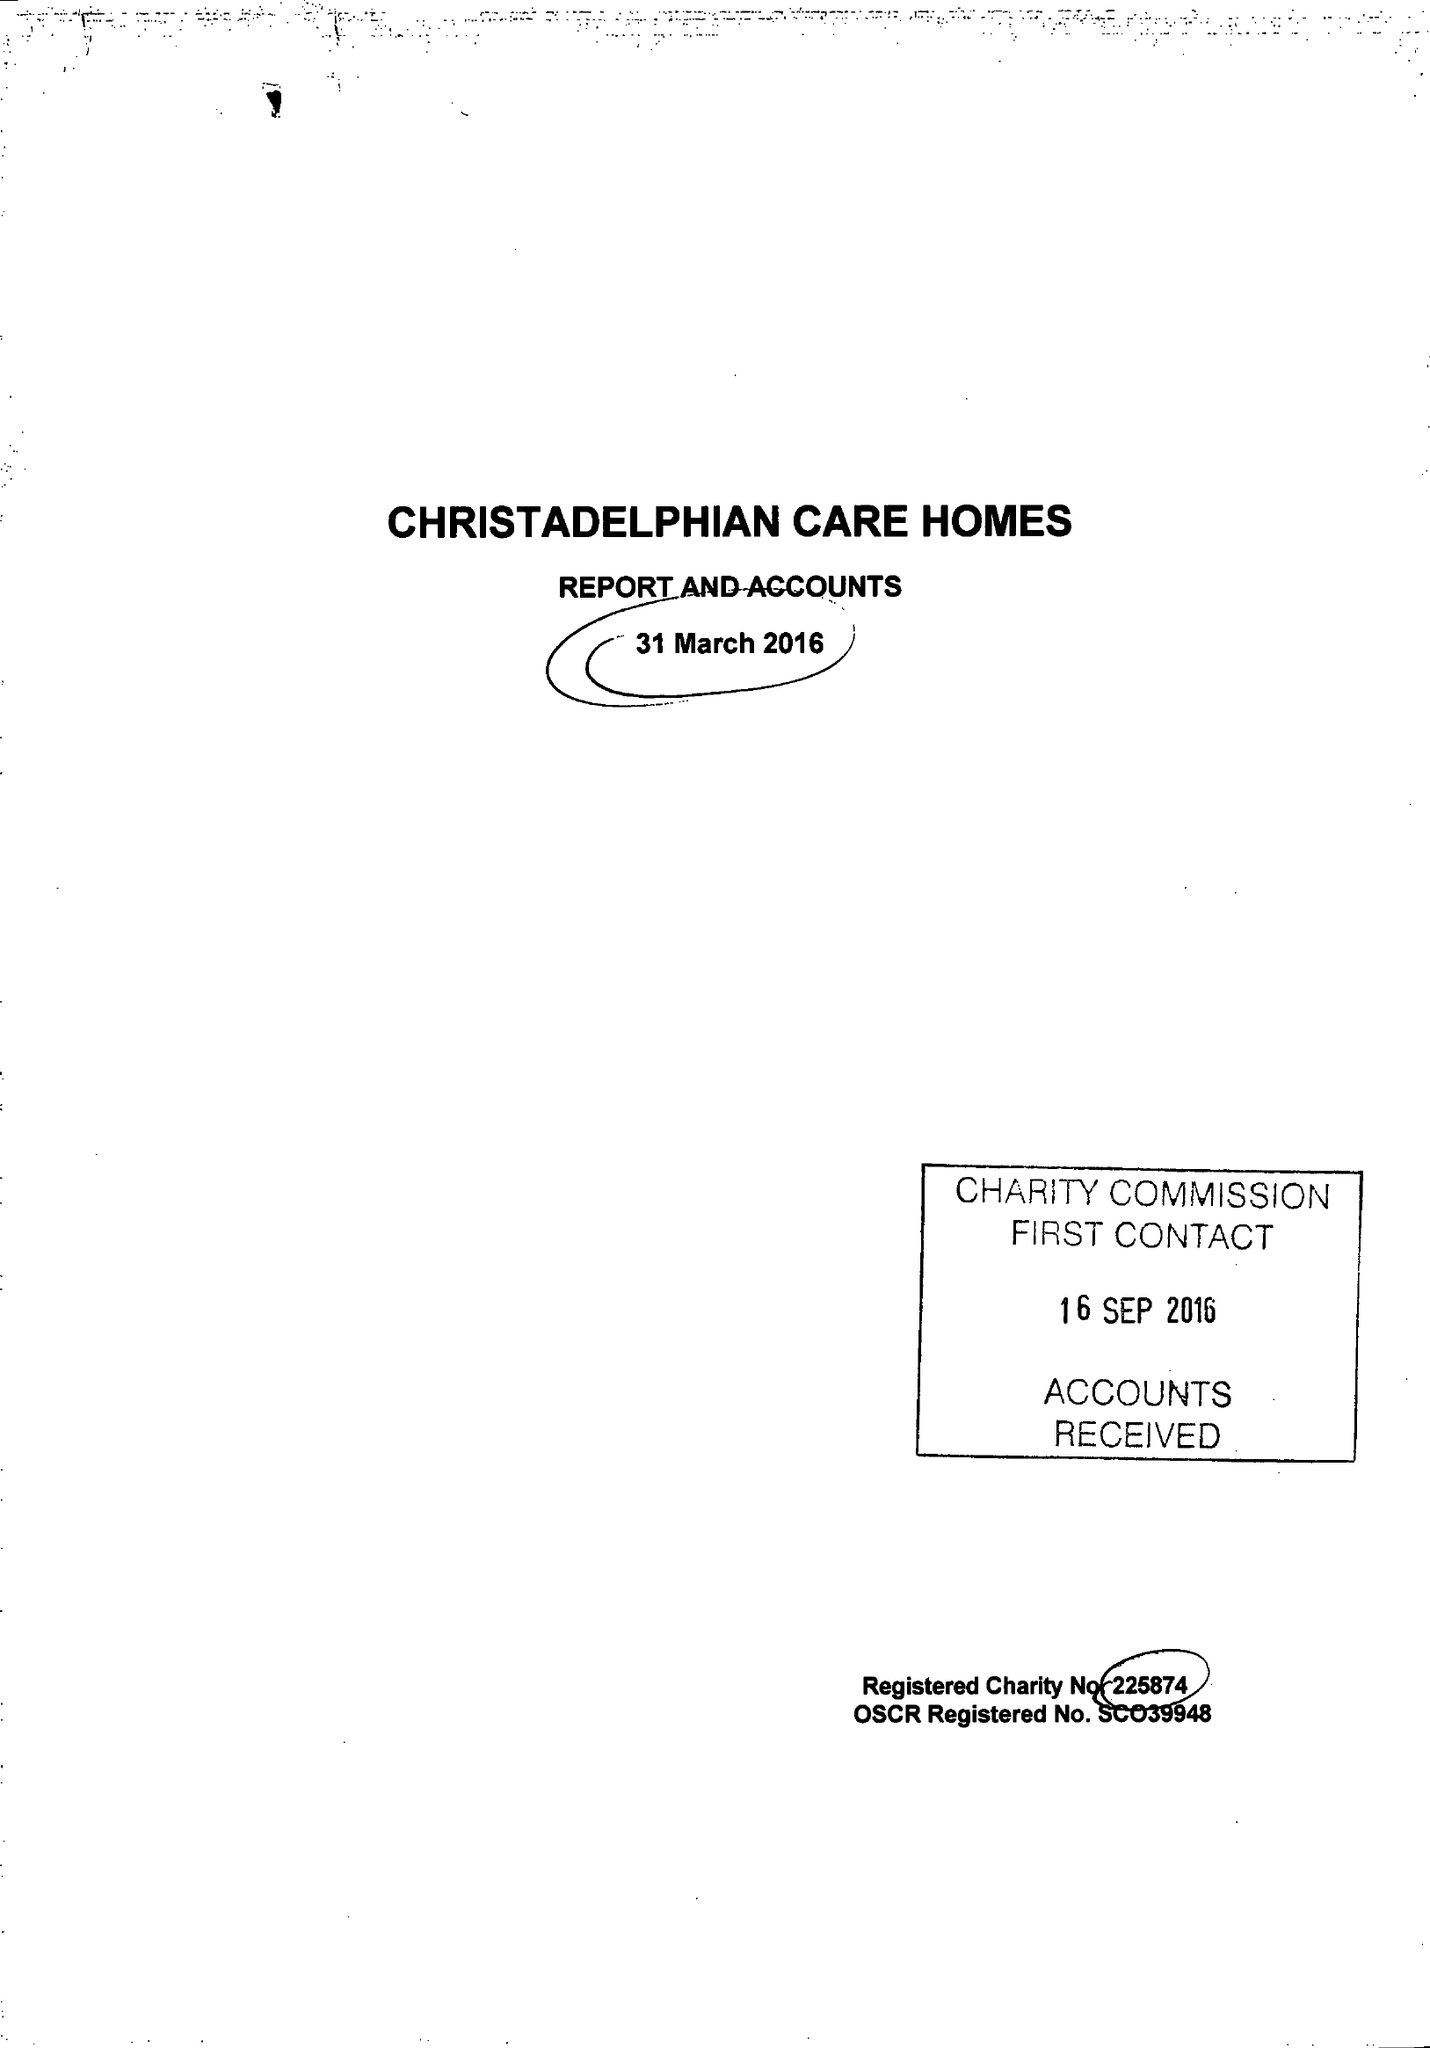What is the value for the address__post_town?
Answer the question using a single word or phrase. BIRMINGHAM 